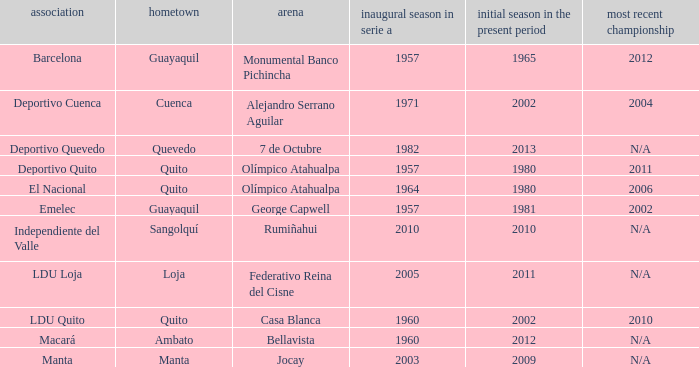Name the last title for 2012 N/A. 